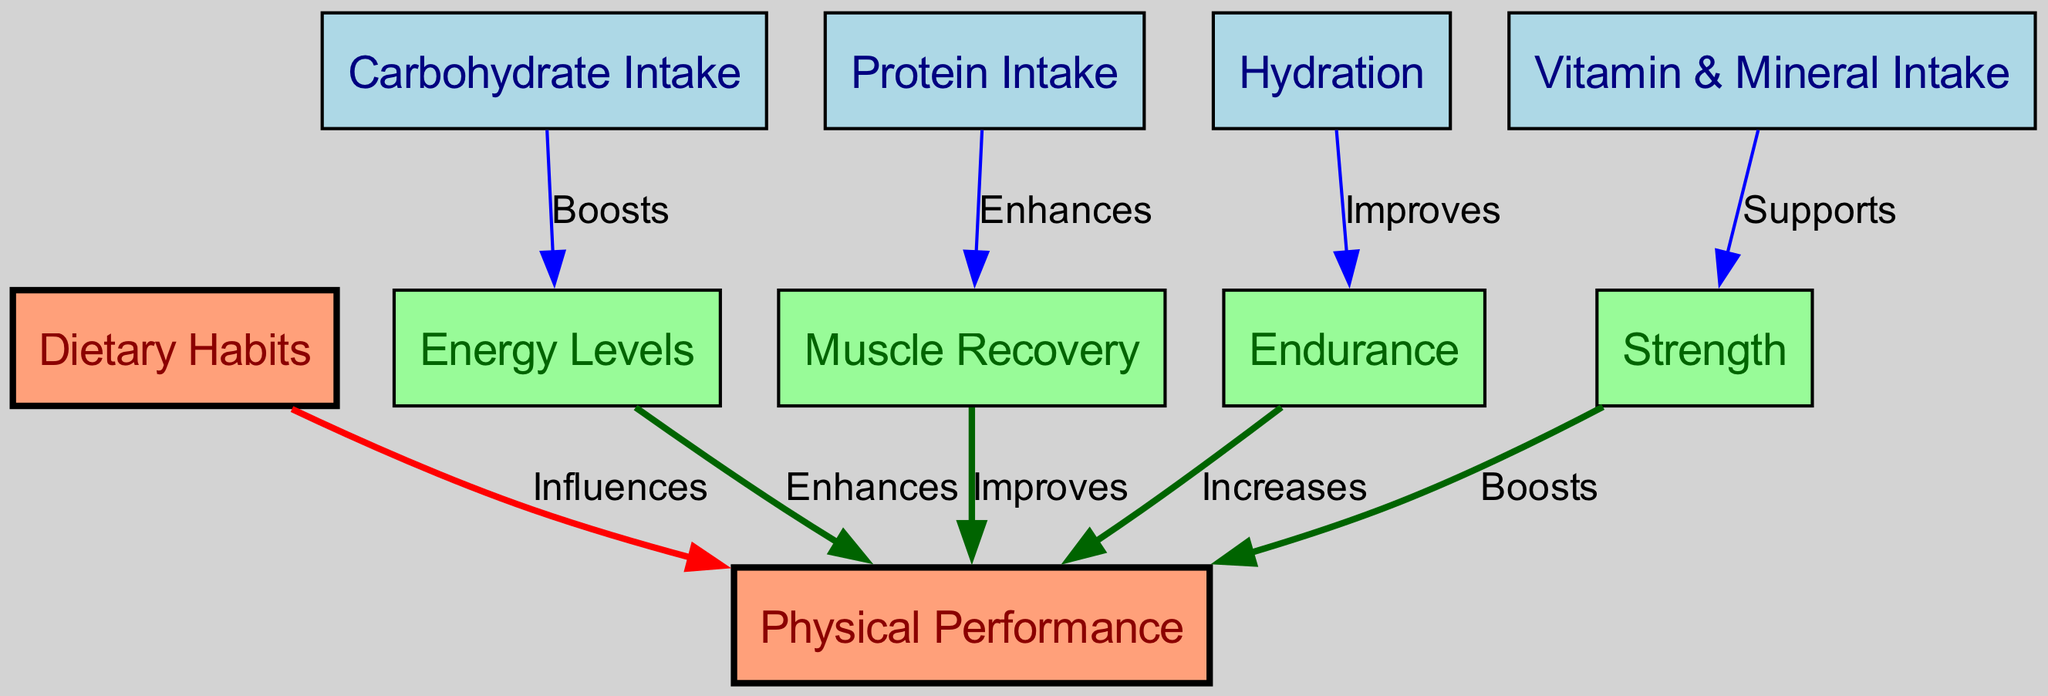What are the two main aspects represented in the diagram? The diagram has two main nodes: "Dietary Habits" and "Physical Performance" which serve as the primary categories being analyzed.
Answer: Dietary Habits, Physical Performance How many nodes are present in the diagram? Counting the individual nodes in the diagram, there are a total of 10 nodes representing different dietary components and performance metrics.
Answer: 10 What relationship does carbohydrate intake have with energy levels? The diagram shows that carbohydrate intake "Boosts" energy levels, indicating a direct positive impact from carbohydrates on the athlete's energy.
Answer: Boosts Which dietary habit is linked to muscle recovery? The arrow from "Protein Intake" to "Muscle Recovery" demonstrates that protein intake is specifically identified as enhancing muscle recovery in athletes.
Answer: Enhances How does hydration affect endurance? The diagram illustrates that hydration "Improves" endurance, indicating a beneficial relationship where proper hydration contributes positively to an athlete's endurance capabilities.
Answer: Improves What effect does muscle recovery have on physical performance? The edge from "Muscle Recovery" to "Physical Performance" indicates that muscle recovery "Improves" physical performance, meaning better recovery can lead to enhanced overall performance for athletes.
Answer: Improves Which node supports strength according to the diagram? The diagram points out that "Vitamin & Mineral Intake" is linked to strength, implying that adequate vitamins and minerals help in enhancing an athlete's strength levels.
Answer: Supports What is the relationship between endurance and physical performance? The diagram shows that endurance "Increases" physical performance, demonstrating that improved endurance capabilities contribute to better overall sports performance.
Answer: Increases How many edges are there connecting dietary habits to physical performance? By analyzing the edges, there are 7 connections showing various ways dietary habits influence or enhance different aspects of physical performance.
Answer: 7 